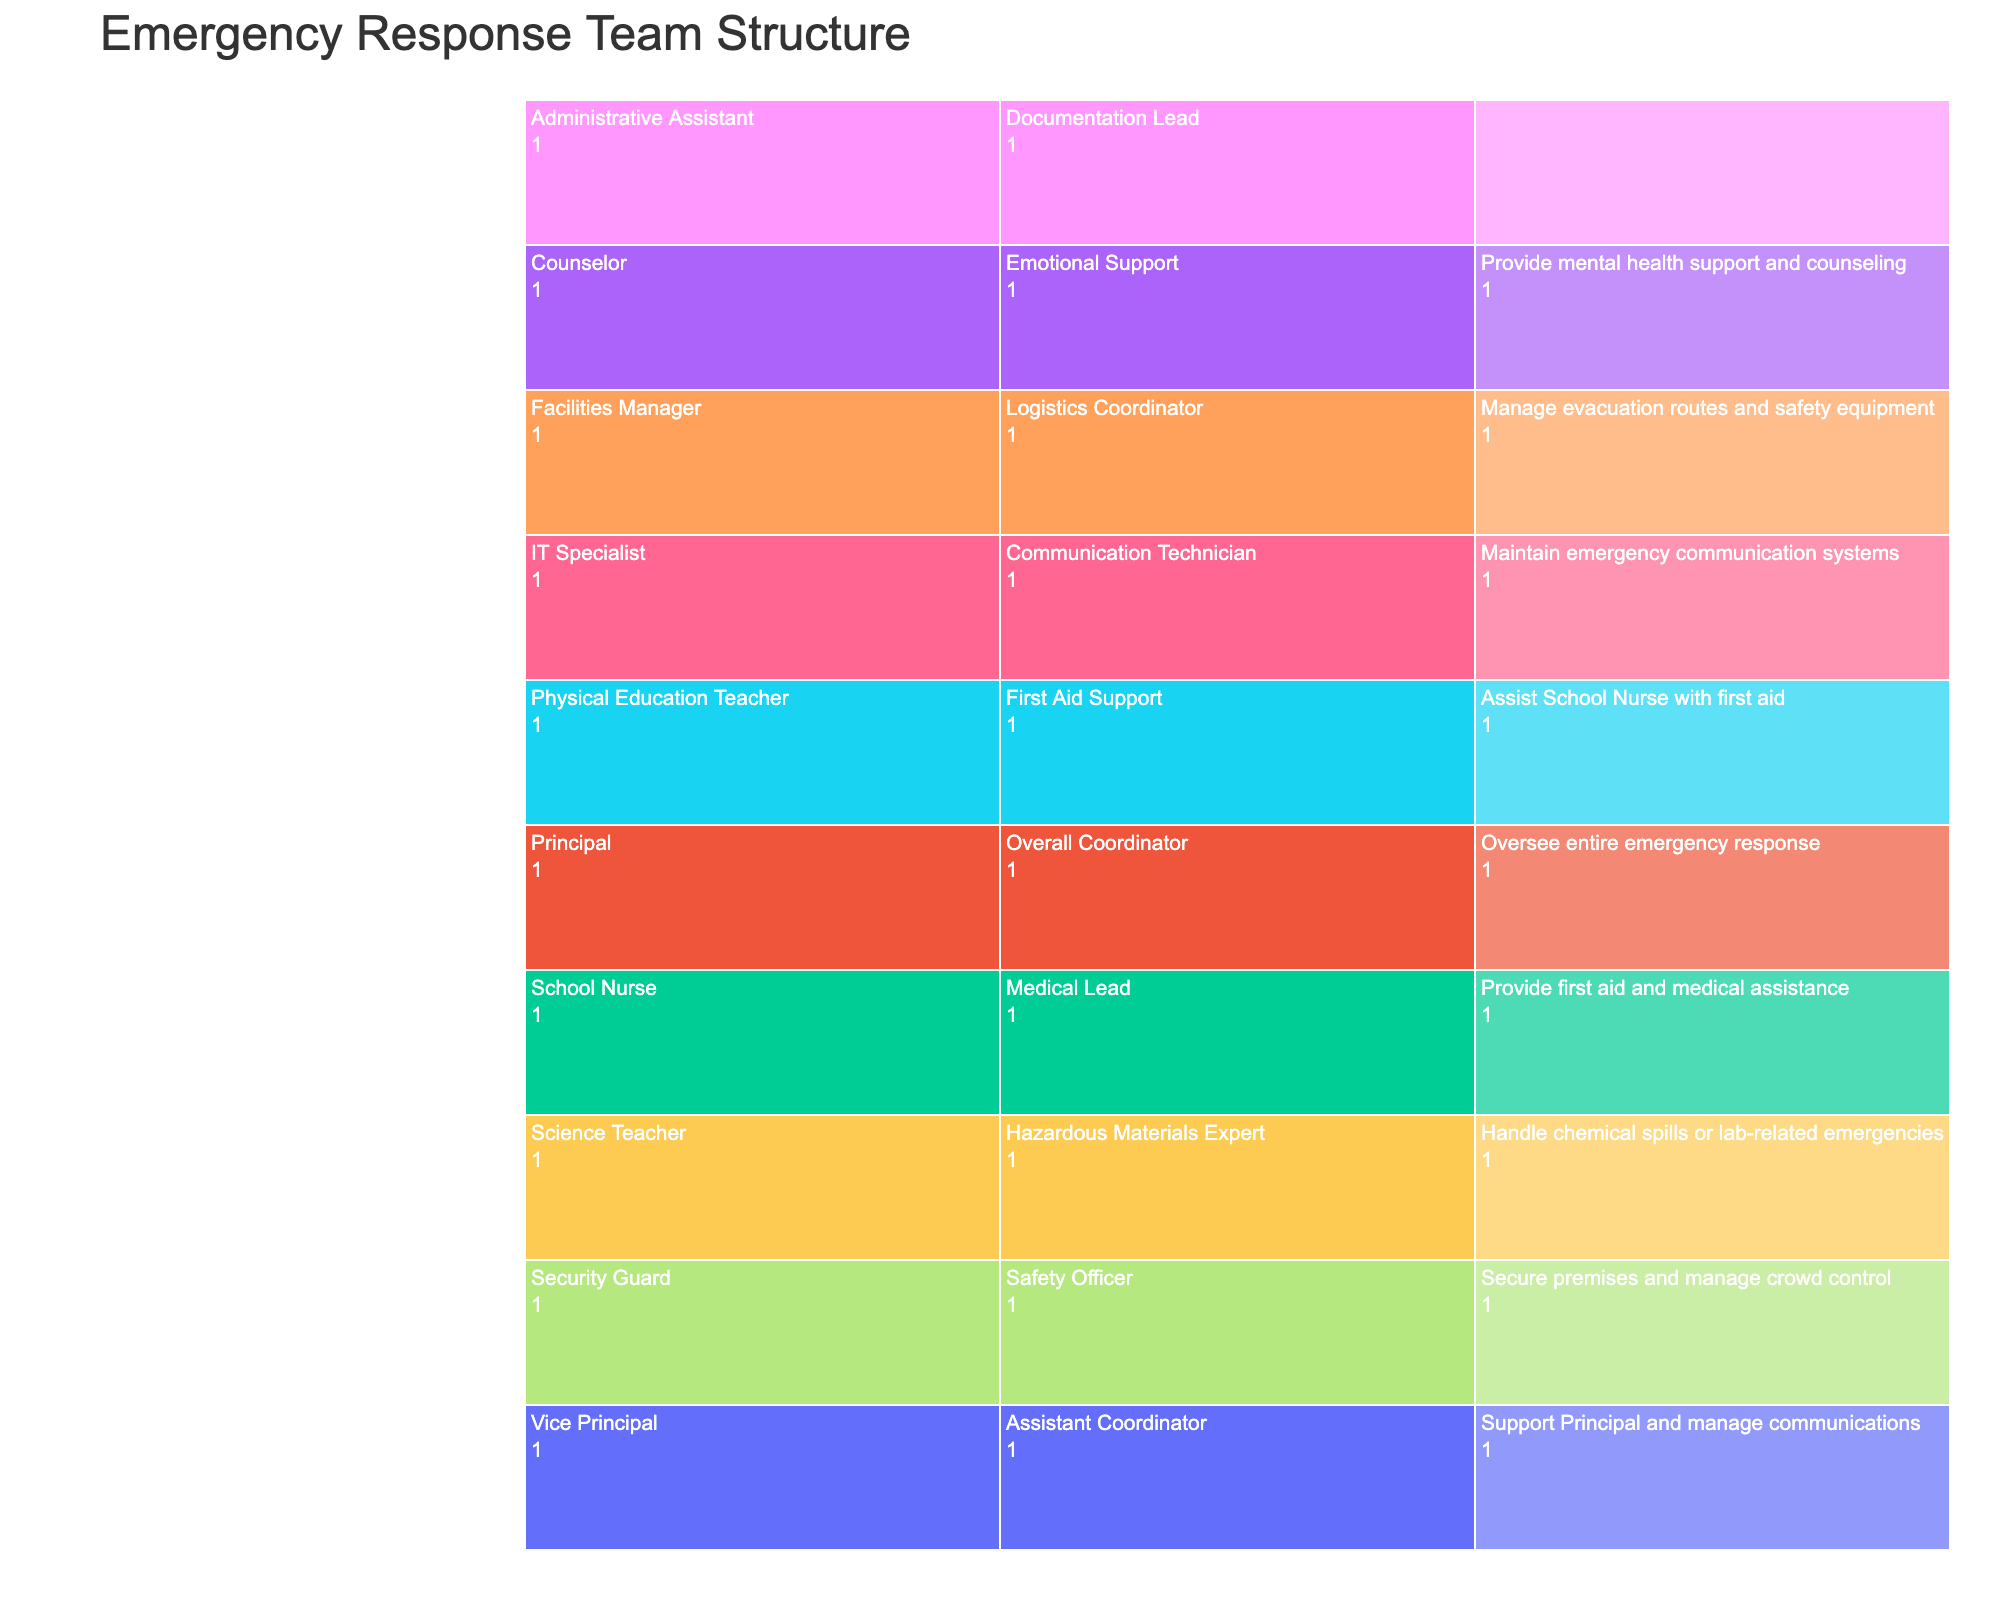What's the title of the figure? The title is usually found at the top of the chart in a larger and bold font. In this case, it would be placed in the layout and not related to data per se but to the chart aesthetics.
Answer: Emergency Response Team Structure How many roles are listed directly under the Principal? The figure will typically display the Principal as the root node, with various branches representing the roles. By looking below the Principal node, you can count how many distinct roles branch out from it.
Answer: One Which role is responsible for managing evacuation routes and safety equipment? Find the role related to "managing evacuation routes and safety equipment." First, locate the role under the Facilities Manager branch and then identify their specific responsibility.
Answer: Logistics Coordinator How many people are involved in providing first aid and medical assistance? Count the individuals whose responsibilities are related to first aid and medical assistance. Look for relevant responsibilities under the role nodes of the School Nurse and the Physical Education Teacher.
Answer: Two Which role has the responsibility to maintain emergency communication systems? Locate the role under the appropriate branch that lists "maintain emergency communication systems" as the responsibility. This will be listed under the IT Specialist branch.
Answer: Communication Technician Who is responsible for securing the premises and managing crowd control? Look for the individual under the relevant branch that describes "securing the premises and managing crowd control." It would be listed under the Security Guard branch.
Answer: Safety Officer Between the Science Teacher and the Physical Education Teacher, who has a responsibility related to hazardous materials? Identify both roles and compare their corresponding responsibilities to determine which one mentions hazardous materials. This would be specifically looking at the Science Teacher vs. the Physical Education Teacher.
Answer: Science Teacher Which role provides mental health support and counseling? Find the individual whose sole responsibility is to provide mental health support and counseling. This will be listed under the Counselor branch.
Answer: Emotional Support What is the role of the Administrative Assistant? Look directly under the Administrative Assistant branch to see what specific responsibility is listed.
Answer: Documentation Lead How is the role of a Safety Officer different from a Medical Lead? Compare the listed responsibilities under both roles to identify distinct differences. The Safety Officer will be responsible for securing the premises while the Medical Lead will be focused on providing first aid and medical assistance.
Answer: Safety Officer: Secure premises; Medical Lead: Provide first aid 